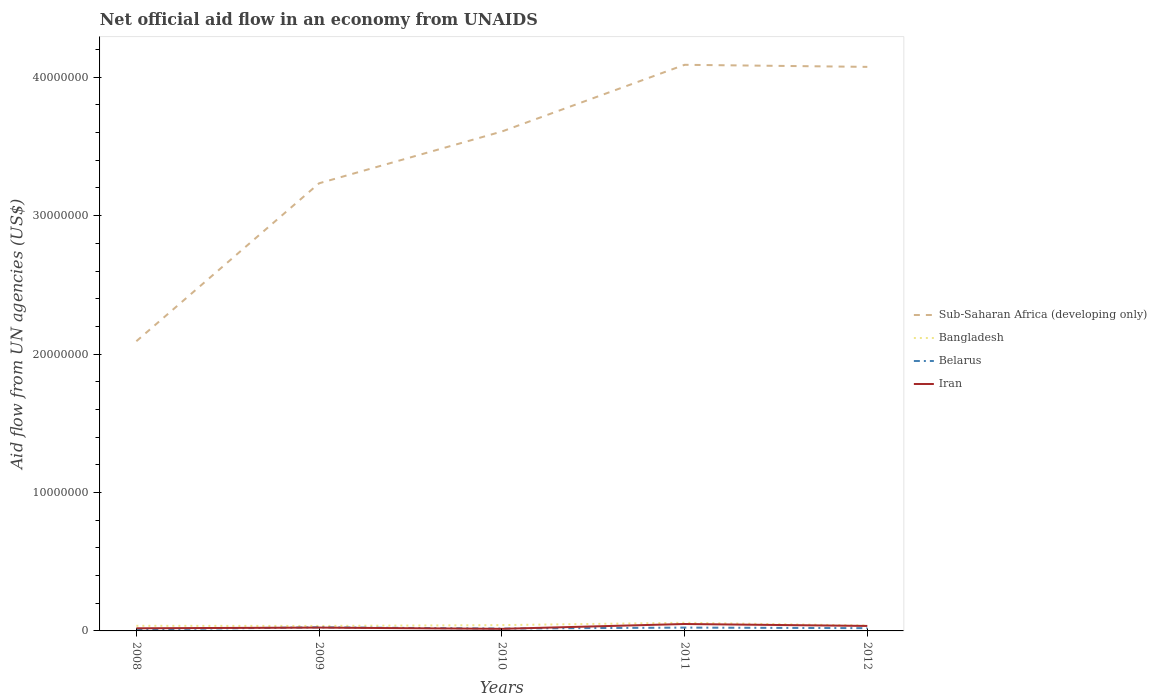How many different coloured lines are there?
Offer a terse response. 4. Does the line corresponding to Sub-Saharan Africa (developing only) intersect with the line corresponding to Iran?
Keep it short and to the point. No. Is the number of lines equal to the number of legend labels?
Make the answer very short. Yes. Across all years, what is the maximum net official aid flow in Bangladesh?
Provide a succinct answer. 3.60e+05. In which year was the net official aid flow in Sub-Saharan Africa (developing only) maximum?
Your response must be concise. 2008. What is the total net official aid flow in Iran in the graph?
Offer a terse response. 4.00e+04. What is the difference between the highest and the second highest net official aid flow in Iran?
Make the answer very short. 3.50e+05. What is the difference between the highest and the lowest net official aid flow in Belarus?
Provide a succinct answer. 3. Is the net official aid flow in Sub-Saharan Africa (developing only) strictly greater than the net official aid flow in Belarus over the years?
Keep it short and to the point. No. How many years are there in the graph?
Your response must be concise. 5. Are the values on the major ticks of Y-axis written in scientific E-notation?
Provide a short and direct response. No. Does the graph contain grids?
Ensure brevity in your answer.  No. Where does the legend appear in the graph?
Make the answer very short. Center right. What is the title of the graph?
Your answer should be compact. Net official aid flow in an economy from UNAIDS. What is the label or title of the Y-axis?
Keep it short and to the point. Aid flow from UN agencies (US$). What is the Aid flow from UN agencies (US$) of Sub-Saharan Africa (developing only) in 2008?
Your answer should be very brief. 2.09e+07. What is the Aid flow from UN agencies (US$) of Belarus in 2008?
Give a very brief answer. 1.10e+05. What is the Aid flow from UN agencies (US$) in Sub-Saharan Africa (developing only) in 2009?
Your answer should be very brief. 3.23e+07. What is the Aid flow from UN agencies (US$) in Iran in 2009?
Your answer should be compact. 2.40e+05. What is the Aid flow from UN agencies (US$) of Sub-Saharan Africa (developing only) in 2010?
Provide a short and direct response. 3.61e+07. What is the Aid flow from UN agencies (US$) in Bangladesh in 2010?
Offer a very short reply. 4.20e+05. What is the Aid flow from UN agencies (US$) in Belarus in 2010?
Provide a short and direct response. 1.70e+05. What is the Aid flow from UN agencies (US$) in Iran in 2010?
Your answer should be very brief. 1.50e+05. What is the Aid flow from UN agencies (US$) in Sub-Saharan Africa (developing only) in 2011?
Your answer should be very brief. 4.09e+07. What is the Aid flow from UN agencies (US$) of Bangladesh in 2011?
Keep it short and to the point. 5.90e+05. What is the Aid flow from UN agencies (US$) of Belarus in 2011?
Offer a very short reply. 2.40e+05. What is the Aid flow from UN agencies (US$) of Iran in 2011?
Give a very brief answer. 5.00e+05. What is the Aid flow from UN agencies (US$) in Sub-Saharan Africa (developing only) in 2012?
Your answer should be compact. 4.08e+07. What is the Aid flow from UN agencies (US$) of Bangladesh in 2012?
Offer a very short reply. 3.90e+05. What is the Aid flow from UN agencies (US$) in Belarus in 2012?
Ensure brevity in your answer.  2.00e+05. Across all years, what is the maximum Aid flow from UN agencies (US$) of Sub-Saharan Africa (developing only)?
Make the answer very short. 4.09e+07. Across all years, what is the maximum Aid flow from UN agencies (US$) in Bangladesh?
Your answer should be compact. 5.90e+05. Across all years, what is the maximum Aid flow from UN agencies (US$) of Iran?
Your answer should be compact. 5.00e+05. Across all years, what is the minimum Aid flow from UN agencies (US$) of Sub-Saharan Africa (developing only)?
Provide a short and direct response. 2.09e+07. Across all years, what is the minimum Aid flow from UN agencies (US$) in Belarus?
Your answer should be compact. 1.10e+05. What is the total Aid flow from UN agencies (US$) in Sub-Saharan Africa (developing only) in the graph?
Your answer should be very brief. 1.71e+08. What is the total Aid flow from UN agencies (US$) of Bangladesh in the graph?
Your response must be concise. 2.13e+06. What is the total Aid flow from UN agencies (US$) in Belarus in the graph?
Give a very brief answer. 9.80e+05. What is the total Aid flow from UN agencies (US$) in Iran in the graph?
Ensure brevity in your answer.  1.44e+06. What is the difference between the Aid flow from UN agencies (US$) of Sub-Saharan Africa (developing only) in 2008 and that in 2009?
Provide a short and direct response. -1.14e+07. What is the difference between the Aid flow from UN agencies (US$) in Iran in 2008 and that in 2009?
Give a very brief answer. -5.00e+04. What is the difference between the Aid flow from UN agencies (US$) in Sub-Saharan Africa (developing only) in 2008 and that in 2010?
Keep it short and to the point. -1.52e+07. What is the difference between the Aid flow from UN agencies (US$) in Sub-Saharan Africa (developing only) in 2008 and that in 2011?
Offer a terse response. -2.00e+07. What is the difference between the Aid flow from UN agencies (US$) of Bangladesh in 2008 and that in 2011?
Your response must be concise. -2.20e+05. What is the difference between the Aid flow from UN agencies (US$) of Iran in 2008 and that in 2011?
Provide a short and direct response. -3.10e+05. What is the difference between the Aid flow from UN agencies (US$) of Sub-Saharan Africa (developing only) in 2008 and that in 2012?
Provide a short and direct response. -1.98e+07. What is the difference between the Aid flow from UN agencies (US$) in Sub-Saharan Africa (developing only) in 2009 and that in 2010?
Make the answer very short. -3.74e+06. What is the difference between the Aid flow from UN agencies (US$) in Belarus in 2009 and that in 2010?
Provide a short and direct response. 9.00e+04. What is the difference between the Aid flow from UN agencies (US$) in Sub-Saharan Africa (developing only) in 2009 and that in 2011?
Give a very brief answer. -8.56e+06. What is the difference between the Aid flow from UN agencies (US$) of Belarus in 2009 and that in 2011?
Provide a succinct answer. 2.00e+04. What is the difference between the Aid flow from UN agencies (US$) of Sub-Saharan Africa (developing only) in 2009 and that in 2012?
Your answer should be very brief. -8.41e+06. What is the difference between the Aid flow from UN agencies (US$) of Bangladesh in 2009 and that in 2012?
Keep it short and to the point. -3.00e+04. What is the difference between the Aid flow from UN agencies (US$) of Belarus in 2009 and that in 2012?
Provide a succinct answer. 6.00e+04. What is the difference between the Aid flow from UN agencies (US$) in Sub-Saharan Africa (developing only) in 2010 and that in 2011?
Your answer should be very brief. -4.82e+06. What is the difference between the Aid flow from UN agencies (US$) in Belarus in 2010 and that in 2011?
Provide a short and direct response. -7.00e+04. What is the difference between the Aid flow from UN agencies (US$) in Iran in 2010 and that in 2011?
Offer a very short reply. -3.50e+05. What is the difference between the Aid flow from UN agencies (US$) of Sub-Saharan Africa (developing only) in 2010 and that in 2012?
Offer a terse response. -4.67e+06. What is the difference between the Aid flow from UN agencies (US$) of Iran in 2010 and that in 2012?
Provide a short and direct response. -2.10e+05. What is the difference between the Aid flow from UN agencies (US$) of Iran in 2011 and that in 2012?
Ensure brevity in your answer.  1.40e+05. What is the difference between the Aid flow from UN agencies (US$) in Sub-Saharan Africa (developing only) in 2008 and the Aid flow from UN agencies (US$) in Bangladesh in 2009?
Your answer should be very brief. 2.06e+07. What is the difference between the Aid flow from UN agencies (US$) in Sub-Saharan Africa (developing only) in 2008 and the Aid flow from UN agencies (US$) in Belarus in 2009?
Give a very brief answer. 2.07e+07. What is the difference between the Aid flow from UN agencies (US$) of Sub-Saharan Africa (developing only) in 2008 and the Aid flow from UN agencies (US$) of Iran in 2009?
Make the answer very short. 2.07e+07. What is the difference between the Aid flow from UN agencies (US$) of Bangladesh in 2008 and the Aid flow from UN agencies (US$) of Belarus in 2009?
Your response must be concise. 1.10e+05. What is the difference between the Aid flow from UN agencies (US$) of Bangladesh in 2008 and the Aid flow from UN agencies (US$) of Iran in 2009?
Provide a succinct answer. 1.30e+05. What is the difference between the Aid flow from UN agencies (US$) in Belarus in 2008 and the Aid flow from UN agencies (US$) in Iran in 2009?
Your response must be concise. -1.30e+05. What is the difference between the Aid flow from UN agencies (US$) of Sub-Saharan Africa (developing only) in 2008 and the Aid flow from UN agencies (US$) of Bangladesh in 2010?
Offer a very short reply. 2.05e+07. What is the difference between the Aid flow from UN agencies (US$) of Sub-Saharan Africa (developing only) in 2008 and the Aid flow from UN agencies (US$) of Belarus in 2010?
Your answer should be compact. 2.08e+07. What is the difference between the Aid flow from UN agencies (US$) in Sub-Saharan Africa (developing only) in 2008 and the Aid flow from UN agencies (US$) in Iran in 2010?
Give a very brief answer. 2.08e+07. What is the difference between the Aid flow from UN agencies (US$) of Sub-Saharan Africa (developing only) in 2008 and the Aid flow from UN agencies (US$) of Bangladesh in 2011?
Provide a succinct answer. 2.03e+07. What is the difference between the Aid flow from UN agencies (US$) in Sub-Saharan Africa (developing only) in 2008 and the Aid flow from UN agencies (US$) in Belarus in 2011?
Keep it short and to the point. 2.07e+07. What is the difference between the Aid flow from UN agencies (US$) of Sub-Saharan Africa (developing only) in 2008 and the Aid flow from UN agencies (US$) of Iran in 2011?
Offer a terse response. 2.04e+07. What is the difference between the Aid flow from UN agencies (US$) of Belarus in 2008 and the Aid flow from UN agencies (US$) of Iran in 2011?
Provide a succinct answer. -3.90e+05. What is the difference between the Aid flow from UN agencies (US$) in Sub-Saharan Africa (developing only) in 2008 and the Aid flow from UN agencies (US$) in Bangladesh in 2012?
Offer a very short reply. 2.05e+07. What is the difference between the Aid flow from UN agencies (US$) in Sub-Saharan Africa (developing only) in 2008 and the Aid flow from UN agencies (US$) in Belarus in 2012?
Provide a short and direct response. 2.07e+07. What is the difference between the Aid flow from UN agencies (US$) of Sub-Saharan Africa (developing only) in 2008 and the Aid flow from UN agencies (US$) of Iran in 2012?
Make the answer very short. 2.06e+07. What is the difference between the Aid flow from UN agencies (US$) of Bangladesh in 2008 and the Aid flow from UN agencies (US$) of Iran in 2012?
Keep it short and to the point. 10000. What is the difference between the Aid flow from UN agencies (US$) in Sub-Saharan Africa (developing only) in 2009 and the Aid flow from UN agencies (US$) in Bangladesh in 2010?
Keep it short and to the point. 3.19e+07. What is the difference between the Aid flow from UN agencies (US$) in Sub-Saharan Africa (developing only) in 2009 and the Aid flow from UN agencies (US$) in Belarus in 2010?
Provide a succinct answer. 3.22e+07. What is the difference between the Aid flow from UN agencies (US$) in Sub-Saharan Africa (developing only) in 2009 and the Aid flow from UN agencies (US$) in Iran in 2010?
Your answer should be compact. 3.22e+07. What is the difference between the Aid flow from UN agencies (US$) in Sub-Saharan Africa (developing only) in 2009 and the Aid flow from UN agencies (US$) in Bangladesh in 2011?
Offer a terse response. 3.18e+07. What is the difference between the Aid flow from UN agencies (US$) in Sub-Saharan Africa (developing only) in 2009 and the Aid flow from UN agencies (US$) in Belarus in 2011?
Provide a short and direct response. 3.21e+07. What is the difference between the Aid flow from UN agencies (US$) of Sub-Saharan Africa (developing only) in 2009 and the Aid flow from UN agencies (US$) of Iran in 2011?
Give a very brief answer. 3.18e+07. What is the difference between the Aid flow from UN agencies (US$) of Bangladesh in 2009 and the Aid flow from UN agencies (US$) of Belarus in 2011?
Your response must be concise. 1.20e+05. What is the difference between the Aid flow from UN agencies (US$) in Sub-Saharan Africa (developing only) in 2009 and the Aid flow from UN agencies (US$) in Bangladesh in 2012?
Provide a short and direct response. 3.20e+07. What is the difference between the Aid flow from UN agencies (US$) in Sub-Saharan Africa (developing only) in 2009 and the Aid flow from UN agencies (US$) in Belarus in 2012?
Offer a very short reply. 3.21e+07. What is the difference between the Aid flow from UN agencies (US$) in Sub-Saharan Africa (developing only) in 2009 and the Aid flow from UN agencies (US$) in Iran in 2012?
Give a very brief answer. 3.20e+07. What is the difference between the Aid flow from UN agencies (US$) of Bangladesh in 2009 and the Aid flow from UN agencies (US$) of Iran in 2012?
Make the answer very short. 0. What is the difference between the Aid flow from UN agencies (US$) in Belarus in 2009 and the Aid flow from UN agencies (US$) in Iran in 2012?
Your answer should be compact. -1.00e+05. What is the difference between the Aid flow from UN agencies (US$) in Sub-Saharan Africa (developing only) in 2010 and the Aid flow from UN agencies (US$) in Bangladesh in 2011?
Provide a short and direct response. 3.55e+07. What is the difference between the Aid flow from UN agencies (US$) in Sub-Saharan Africa (developing only) in 2010 and the Aid flow from UN agencies (US$) in Belarus in 2011?
Your response must be concise. 3.58e+07. What is the difference between the Aid flow from UN agencies (US$) in Sub-Saharan Africa (developing only) in 2010 and the Aid flow from UN agencies (US$) in Iran in 2011?
Ensure brevity in your answer.  3.56e+07. What is the difference between the Aid flow from UN agencies (US$) of Bangladesh in 2010 and the Aid flow from UN agencies (US$) of Belarus in 2011?
Make the answer very short. 1.80e+05. What is the difference between the Aid flow from UN agencies (US$) in Bangladesh in 2010 and the Aid flow from UN agencies (US$) in Iran in 2011?
Ensure brevity in your answer.  -8.00e+04. What is the difference between the Aid flow from UN agencies (US$) of Belarus in 2010 and the Aid flow from UN agencies (US$) of Iran in 2011?
Give a very brief answer. -3.30e+05. What is the difference between the Aid flow from UN agencies (US$) in Sub-Saharan Africa (developing only) in 2010 and the Aid flow from UN agencies (US$) in Bangladesh in 2012?
Give a very brief answer. 3.57e+07. What is the difference between the Aid flow from UN agencies (US$) of Sub-Saharan Africa (developing only) in 2010 and the Aid flow from UN agencies (US$) of Belarus in 2012?
Provide a short and direct response. 3.59e+07. What is the difference between the Aid flow from UN agencies (US$) in Sub-Saharan Africa (developing only) in 2010 and the Aid flow from UN agencies (US$) in Iran in 2012?
Provide a succinct answer. 3.57e+07. What is the difference between the Aid flow from UN agencies (US$) of Bangladesh in 2010 and the Aid flow from UN agencies (US$) of Belarus in 2012?
Provide a short and direct response. 2.20e+05. What is the difference between the Aid flow from UN agencies (US$) of Bangladesh in 2010 and the Aid flow from UN agencies (US$) of Iran in 2012?
Give a very brief answer. 6.00e+04. What is the difference between the Aid flow from UN agencies (US$) of Sub-Saharan Africa (developing only) in 2011 and the Aid flow from UN agencies (US$) of Bangladesh in 2012?
Ensure brevity in your answer.  4.05e+07. What is the difference between the Aid flow from UN agencies (US$) in Sub-Saharan Africa (developing only) in 2011 and the Aid flow from UN agencies (US$) in Belarus in 2012?
Your answer should be compact. 4.07e+07. What is the difference between the Aid flow from UN agencies (US$) of Sub-Saharan Africa (developing only) in 2011 and the Aid flow from UN agencies (US$) of Iran in 2012?
Your answer should be compact. 4.05e+07. What is the difference between the Aid flow from UN agencies (US$) in Bangladesh in 2011 and the Aid flow from UN agencies (US$) in Belarus in 2012?
Make the answer very short. 3.90e+05. What is the difference between the Aid flow from UN agencies (US$) of Bangladesh in 2011 and the Aid flow from UN agencies (US$) of Iran in 2012?
Your response must be concise. 2.30e+05. What is the difference between the Aid flow from UN agencies (US$) in Belarus in 2011 and the Aid flow from UN agencies (US$) in Iran in 2012?
Offer a very short reply. -1.20e+05. What is the average Aid flow from UN agencies (US$) in Sub-Saharan Africa (developing only) per year?
Offer a very short reply. 3.42e+07. What is the average Aid flow from UN agencies (US$) in Bangladesh per year?
Ensure brevity in your answer.  4.26e+05. What is the average Aid flow from UN agencies (US$) in Belarus per year?
Provide a short and direct response. 1.96e+05. What is the average Aid flow from UN agencies (US$) in Iran per year?
Give a very brief answer. 2.88e+05. In the year 2008, what is the difference between the Aid flow from UN agencies (US$) of Sub-Saharan Africa (developing only) and Aid flow from UN agencies (US$) of Bangladesh?
Ensure brevity in your answer.  2.06e+07. In the year 2008, what is the difference between the Aid flow from UN agencies (US$) in Sub-Saharan Africa (developing only) and Aid flow from UN agencies (US$) in Belarus?
Give a very brief answer. 2.08e+07. In the year 2008, what is the difference between the Aid flow from UN agencies (US$) in Sub-Saharan Africa (developing only) and Aid flow from UN agencies (US$) in Iran?
Offer a terse response. 2.07e+07. In the year 2008, what is the difference between the Aid flow from UN agencies (US$) in Bangladesh and Aid flow from UN agencies (US$) in Iran?
Make the answer very short. 1.80e+05. In the year 2009, what is the difference between the Aid flow from UN agencies (US$) in Sub-Saharan Africa (developing only) and Aid flow from UN agencies (US$) in Bangladesh?
Provide a succinct answer. 3.20e+07. In the year 2009, what is the difference between the Aid flow from UN agencies (US$) of Sub-Saharan Africa (developing only) and Aid flow from UN agencies (US$) of Belarus?
Offer a very short reply. 3.21e+07. In the year 2009, what is the difference between the Aid flow from UN agencies (US$) in Sub-Saharan Africa (developing only) and Aid flow from UN agencies (US$) in Iran?
Your response must be concise. 3.21e+07. In the year 2009, what is the difference between the Aid flow from UN agencies (US$) in Bangladesh and Aid flow from UN agencies (US$) in Belarus?
Keep it short and to the point. 1.00e+05. In the year 2009, what is the difference between the Aid flow from UN agencies (US$) in Belarus and Aid flow from UN agencies (US$) in Iran?
Provide a short and direct response. 2.00e+04. In the year 2010, what is the difference between the Aid flow from UN agencies (US$) in Sub-Saharan Africa (developing only) and Aid flow from UN agencies (US$) in Bangladesh?
Offer a terse response. 3.57e+07. In the year 2010, what is the difference between the Aid flow from UN agencies (US$) in Sub-Saharan Africa (developing only) and Aid flow from UN agencies (US$) in Belarus?
Your answer should be compact. 3.59e+07. In the year 2010, what is the difference between the Aid flow from UN agencies (US$) in Sub-Saharan Africa (developing only) and Aid flow from UN agencies (US$) in Iran?
Offer a terse response. 3.59e+07. In the year 2011, what is the difference between the Aid flow from UN agencies (US$) of Sub-Saharan Africa (developing only) and Aid flow from UN agencies (US$) of Bangladesh?
Your answer should be compact. 4.03e+07. In the year 2011, what is the difference between the Aid flow from UN agencies (US$) in Sub-Saharan Africa (developing only) and Aid flow from UN agencies (US$) in Belarus?
Keep it short and to the point. 4.07e+07. In the year 2011, what is the difference between the Aid flow from UN agencies (US$) in Sub-Saharan Africa (developing only) and Aid flow from UN agencies (US$) in Iran?
Provide a short and direct response. 4.04e+07. In the year 2011, what is the difference between the Aid flow from UN agencies (US$) in Bangladesh and Aid flow from UN agencies (US$) in Belarus?
Provide a short and direct response. 3.50e+05. In the year 2011, what is the difference between the Aid flow from UN agencies (US$) in Bangladesh and Aid flow from UN agencies (US$) in Iran?
Provide a short and direct response. 9.00e+04. In the year 2011, what is the difference between the Aid flow from UN agencies (US$) in Belarus and Aid flow from UN agencies (US$) in Iran?
Ensure brevity in your answer.  -2.60e+05. In the year 2012, what is the difference between the Aid flow from UN agencies (US$) of Sub-Saharan Africa (developing only) and Aid flow from UN agencies (US$) of Bangladesh?
Offer a very short reply. 4.04e+07. In the year 2012, what is the difference between the Aid flow from UN agencies (US$) in Sub-Saharan Africa (developing only) and Aid flow from UN agencies (US$) in Belarus?
Your answer should be very brief. 4.06e+07. In the year 2012, what is the difference between the Aid flow from UN agencies (US$) of Sub-Saharan Africa (developing only) and Aid flow from UN agencies (US$) of Iran?
Provide a succinct answer. 4.04e+07. What is the ratio of the Aid flow from UN agencies (US$) of Sub-Saharan Africa (developing only) in 2008 to that in 2009?
Make the answer very short. 0.65. What is the ratio of the Aid flow from UN agencies (US$) of Bangladesh in 2008 to that in 2009?
Keep it short and to the point. 1.03. What is the ratio of the Aid flow from UN agencies (US$) in Belarus in 2008 to that in 2009?
Provide a succinct answer. 0.42. What is the ratio of the Aid flow from UN agencies (US$) in Iran in 2008 to that in 2009?
Provide a short and direct response. 0.79. What is the ratio of the Aid flow from UN agencies (US$) in Sub-Saharan Africa (developing only) in 2008 to that in 2010?
Your answer should be compact. 0.58. What is the ratio of the Aid flow from UN agencies (US$) of Bangladesh in 2008 to that in 2010?
Ensure brevity in your answer.  0.88. What is the ratio of the Aid flow from UN agencies (US$) in Belarus in 2008 to that in 2010?
Your response must be concise. 0.65. What is the ratio of the Aid flow from UN agencies (US$) in Iran in 2008 to that in 2010?
Keep it short and to the point. 1.27. What is the ratio of the Aid flow from UN agencies (US$) in Sub-Saharan Africa (developing only) in 2008 to that in 2011?
Keep it short and to the point. 0.51. What is the ratio of the Aid flow from UN agencies (US$) of Bangladesh in 2008 to that in 2011?
Provide a short and direct response. 0.63. What is the ratio of the Aid flow from UN agencies (US$) of Belarus in 2008 to that in 2011?
Give a very brief answer. 0.46. What is the ratio of the Aid flow from UN agencies (US$) in Iran in 2008 to that in 2011?
Provide a succinct answer. 0.38. What is the ratio of the Aid flow from UN agencies (US$) of Sub-Saharan Africa (developing only) in 2008 to that in 2012?
Give a very brief answer. 0.51. What is the ratio of the Aid flow from UN agencies (US$) of Bangladesh in 2008 to that in 2012?
Give a very brief answer. 0.95. What is the ratio of the Aid flow from UN agencies (US$) in Belarus in 2008 to that in 2012?
Provide a short and direct response. 0.55. What is the ratio of the Aid flow from UN agencies (US$) of Iran in 2008 to that in 2012?
Give a very brief answer. 0.53. What is the ratio of the Aid flow from UN agencies (US$) in Sub-Saharan Africa (developing only) in 2009 to that in 2010?
Give a very brief answer. 0.9. What is the ratio of the Aid flow from UN agencies (US$) in Belarus in 2009 to that in 2010?
Offer a very short reply. 1.53. What is the ratio of the Aid flow from UN agencies (US$) of Sub-Saharan Africa (developing only) in 2009 to that in 2011?
Make the answer very short. 0.79. What is the ratio of the Aid flow from UN agencies (US$) of Bangladesh in 2009 to that in 2011?
Provide a succinct answer. 0.61. What is the ratio of the Aid flow from UN agencies (US$) of Iran in 2009 to that in 2011?
Give a very brief answer. 0.48. What is the ratio of the Aid flow from UN agencies (US$) in Sub-Saharan Africa (developing only) in 2009 to that in 2012?
Offer a terse response. 0.79. What is the ratio of the Aid flow from UN agencies (US$) in Bangladesh in 2009 to that in 2012?
Give a very brief answer. 0.92. What is the ratio of the Aid flow from UN agencies (US$) in Belarus in 2009 to that in 2012?
Ensure brevity in your answer.  1.3. What is the ratio of the Aid flow from UN agencies (US$) of Sub-Saharan Africa (developing only) in 2010 to that in 2011?
Make the answer very short. 0.88. What is the ratio of the Aid flow from UN agencies (US$) of Bangladesh in 2010 to that in 2011?
Offer a very short reply. 0.71. What is the ratio of the Aid flow from UN agencies (US$) of Belarus in 2010 to that in 2011?
Provide a short and direct response. 0.71. What is the ratio of the Aid flow from UN agencies (US$) of Sub-Saharan Africa (developing only) in 2010 to that in 2012?
Provide a short and direct response. 0.89. What is the ratio of the Aid flow from UN agencies (US$) of Iran in 2010 to that in 2012?
Provide a succinct answer. 0.42. What is the ratio of the Aid flow from UN agencies (US$) in Bangladesh in 2011 to that in 2012?
Provide a succinct answer. 1.51. What is the ratio of the Aid flow from UN agencies (US$) in Belarus in 2011 to that in 2012?
Provide a succinct answer. 1.2. What is the ratio of the Aid flow from UN agencies (US$) in Iran in 2011 to that in 2012?
Keep it short and to the point. 1.39. What is the difference between the highest and the second highest Aid flow from UN agencies (US$) of Belarus?
Your answer should be very brief. 2.00e+04. What is the difference between the highest and the lowest Aid flow from UN agencies (US$) in Sub-Saharan Africa (developing only)?
Provide a short and direct response. 2.00e+07. What is the difference between the highest and the lowest Aid flow from UN agencies (US$) of Bangladesh?
Give a very brief answer. 2.30e+05. What is the difference between the highest and the lowest Aid flow from UN agencies (US$) of Belarus?
Offer a very short reply. 1.50e+05. 